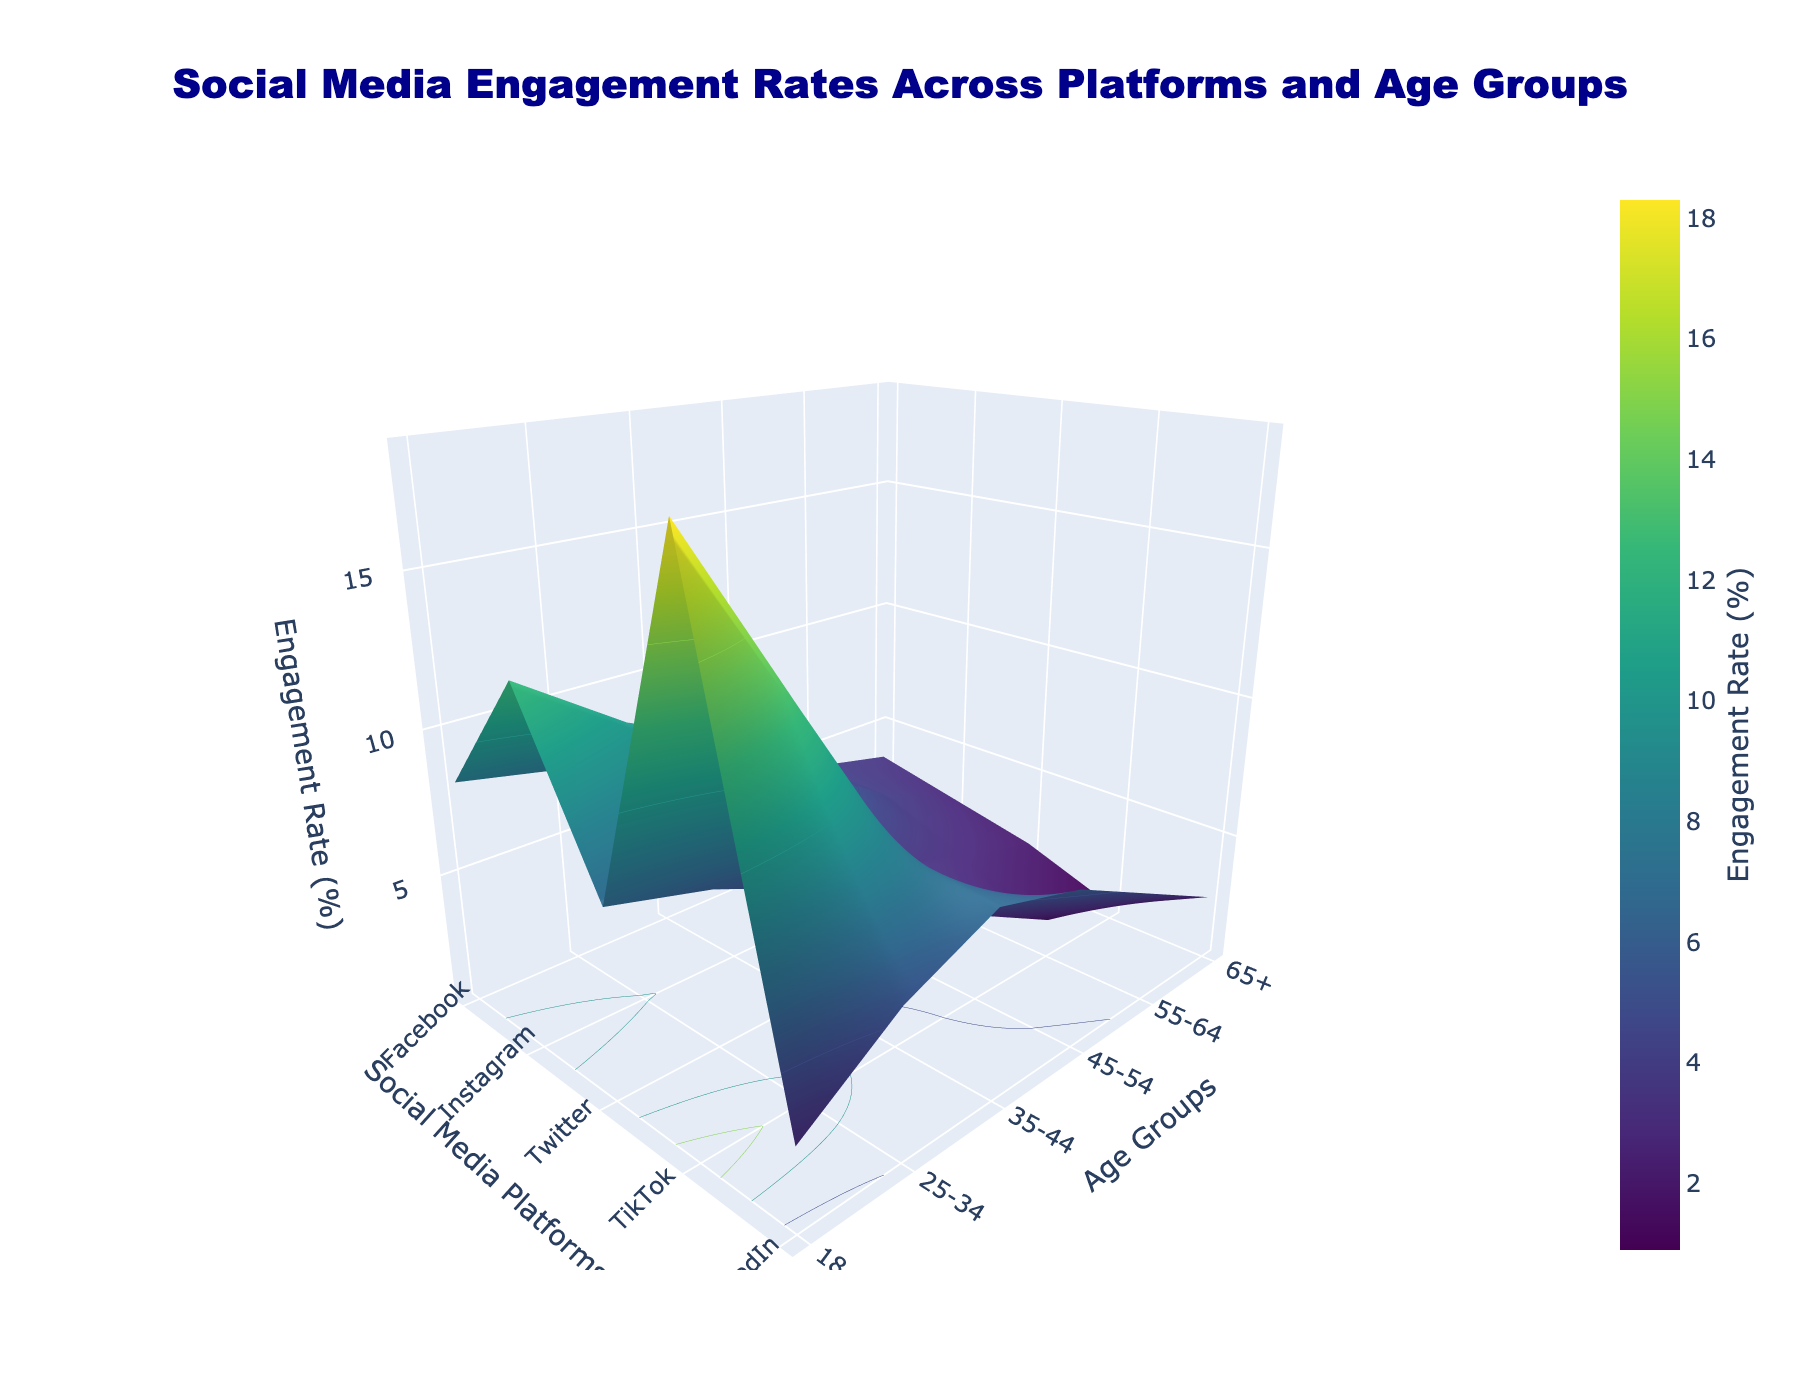Which age group has the highest engagement rate on TikTok? Look at the TikTok axis and identify the maximum z-value. Find the corresponding age group on the y-axis.
Answer: 18-24 Which social media platform has the lowest engagement rate for the 65+ age group? Find the 65+ age group on the y-axis and identify the minimum z-value across the platforms.
Answer: TikTok What is the difference in engagement rate between Facebook and LinkedIn for the 35-44 age group? Find the 35-44 age group on the y-axis, locate the z-values for Facebook and LinkedIn, and then compute the difference.
Answer: -0.5 On which social media platform is the engagement rate decreasing the most rapidly as age increases? Observe the overall trend in the z-values for each platform as you move from lower to higher age groups. Identify which platform shows the steepest decline.
Answer: TikTok What is the average engagement rate across all platforms for the 25-34 age group? Find the z-values for the 25-34 age group on the y-axis and compute their average. The values are (7.5, 10.2, 5.9, 12.7, 5.4), so the average is (7.5 + 10.2 + 5.9 + 12.7 + 5.4) / 5 = 41.7 / 5 = 8.34
Answer: 8.34 Which age group has the closest engagement rates between Facebook and Instagram? Compare the z-values for Facebook and Instagram for each age group and identify the pair with the smallest difference.
Answer: 55-64 Compare the engagement rates on Facebook and TikTok for the 45-54 age group, which is higher? Identify the z-values for Facebook and TikTok for the 45-54 age group and compare them.
Answer: Facebook What is the overall trend in engagement rates for LinkedIn as age increases? Observe the LinkedIn axis and check if the z-values generally increase, decrease, or remain constant as you move from the youngest to the oldest age group.
Answer: Increase Examine the engagement rates for the 18-24 and 55-64 age groups on Instagram. Which group has the higher rate? By how much? Identify the z-values for Instagram for both age groups and compute the difference. The 18-24 rate is 12.5 and the 55-64 rate is 4.1, so the difference is 12.5 - 4.1 = 8.4
Answer: 18-24, 8.4 How does the engagement rate for Twitter compare between the youngest and oldest age groups? Identify the z-values for Twitter for the 18-24 and 65+ age groups and compare them. The 18-24 rate is 6.8 and the 65+ rate is 2.1.
Answer: 18-24 is higher 